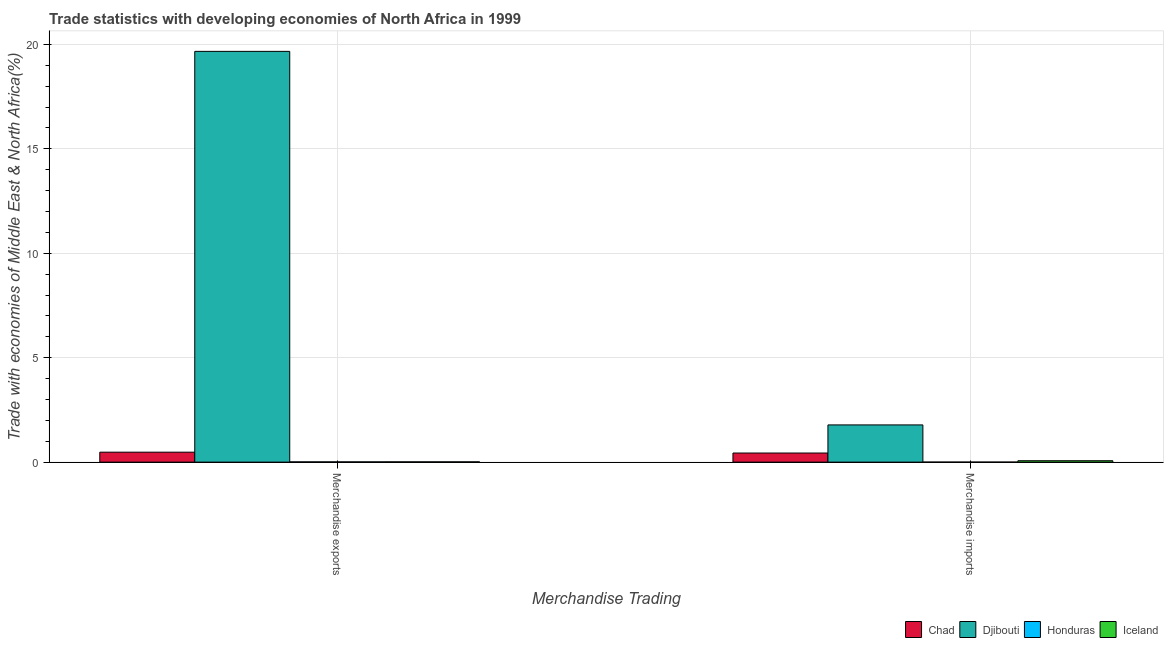How many groups of bars are there?
Your response must be concise. 2. What is the label of the 2nd group of bars from the left?
Make the answer very short. Merchandise imports. What is the merchandise imports in Honduras?
Provide a succinct answer. 0. Across all countries, what is the maximum merchandise exports?
Provide a succinct answer. 19.67. Across all countries, what is the minimum merchandise imports?
Offer a very short reply. 0. In which country was the merchandise imports maximum?
Offer a very short reply. Djibouti. In which country was the merchandise exports minimum?
Give a very brief answer. Honduras. What is the total merchandise imports in the graph?
Keep it short and to the point. 2.29. What is the difference between the merchandise exports in Iceland and that in Djibouti?
Ensure brevity in your answer.  -19.66. What is the difference between the merchandise imports in Chad and the merchandise exports in Honduras?
Make the answer very short. 0.42. What is the average merchandise imports per country?
Make the answer very short. 0.57. What is the difference between the merchandise imports and merchandise exports in Djibouti?
Your answer should be very brief. -17.89. In how many countries, is the merchandise exports greater than 14 %?
Offer a terse response. 1. What is the ratio of the merchandise exports in Djibouti to that in Honduras?
Give a very brief answer. 1712.15. Is the merchandise exports in Djibouti less than that in Honduras?
Keep it short and to the point. No. What does the 1st bar from the left in Merchandise exports represents?
Provide a short and direct response. Chad. How many bars are there?
Offer a very short reply. 8. Are all the bars in the graph horizontal?
Give a very brief answer. No. How many countries are there in the graph?
Provide a short and direct response. 4. What is the difference between two consecutive major ticks on the Y-axis?
Your answer should be very brief. 5. Are the values on the major ticks of Y-axis written in scientific E-notation?
Provide a succinct answer. No. Does the graph contain any zero values?
Your answer should be very brief. No. Does the graph contain grids?
Ensure brevity in your answer.  Yes. Where does the legend appear in the graph?
Provide a succinct answer. Bottom right. How are the legend labels stacked?
Your response must be concise. Horizontal. What is the title of the graph?
Your answer should be very brief. Trade statistics with developing economies of North Africa in 1999. What is the label or title of the X-axis?
Provide a succinct answer. Merchandise Trading. What is the label or title of the Y-axis?
Provide a succinct answer. Trade with economies of Middle East & North Africa(%). What is the Trade with economies of Middle East & North Africa(%) in Chad in Merchandise exports?
Keep it short and to the point. 0.48. What is the Trade with economies of Middle East & North Africa(%) in Djibouti in Merchandise exports?
Keep it short and to the point. 19.67. What is the Trade with economies of Middle East & North Africa(%) in Honduras in Merchandise exports?
Your answer should be very brief. 0.01. What is the Trade with economies of Middle East & North Africa(%) of Iceland in Merchandise exports?
Give a very brief answer. 0.01. What is the Trade with economies of Middle East & North Africa(%) of Chad in Merchandise imports?
Provide a succinct answer. 0.44. What is the Trade with economies of Middle East & North Africa(%) of Djibouti in Merchandise imports?
Offer a very short reply. 1.78. What is the Trade with economies of Middle East & North Africa(%) in Honduras in Merchandise imports?
Your answer should be compact. 0. What is the Trade with economies of Middle East & North Africa(%) of Iceland in Merchandise imports?
Ensure brevity in your answer.  0.07. Across all Merchandise Trading, what is the maximum Trade with economies of Middle East & North Africa(%) in Chad?
Your response must be concise. 0.48. Across all Merchandise Trading, what is the maximum Trade with economies of Middle East & North Africa(%) in Djibouti?
Your answer should be compact. 19.67. Across all Merchandise Trading, what is the maximum Trade with economies of Middle East & North Africa(%) of Honduras?
Provide a short and direct response. 0.01. Across all Merchandise Trading, what is the maximum Trade with economies of Middle East & North Africa(%) of Iceland?
Provide a succinct answer. 0.07. Across all Merchandise Trading, what is the minimum Trade with economies of Middle East & North Africa(%) of Chad?
Offer a very short reply. 0.44. Across all Merchandise Trading, what is the minimum Trade with economies of Middle East & North Africa(%) in Djibouti?
Ensure brevity in your answer.  1.78. Across all Merchandise Trading, what is the minimum Trade with economies of Middle East & North Africa(%) of Honduras?
Give a very brief answer. 0. Across all Merchandise Trading, what is the minimum Trade with economies of Middle East & North Africa(%) in Iceland?
Provide a short and direct response. 0.01. What is the total Trade with economies of Middle East & North Africa(%) of Chad in the graph?
Make the answer very short. 0.91. What is the total Trade with economies of Middle East & North Africa(%) of Djibouti in the graph?
Provide a succinct answer. 21.45. What is the total Trade with economies of Middle East & North Africa(%) of Honduras in the graph?
Your answer should be compact. 0.01. What is the difference between the Trade with economies of Middle East & North Africa(%) of Chad in Merchandise exports and that in Merchandise imports?
Provide a succinct answer. 0.04. What is the difference between the Trade with economies of Middle East & North Africa(%) in Djibouti in Merchandise exports and that in Merchandise imports?
Make the answer very short. 17.89. What is the difference between the Trade with economies of Middle East & North Africa(%) in Honduras in Merchandise exports and that in Merchandise imports?
Make the answer very short. 0.01. What is the difference between the Trade with economies of Middle East & North Africa(%) in Iceland in Merchandise exports and that in Merchandise imports?
Your answer should be very brief. -0.05. What is the difference between the Trade with economies of Middle East & North Africa(%) in Chad in Merchandise exports and the Trade with economies of Middle East & North Africa(%) in Djibouti in Merchandise imports?
Offer a terse response. -1.31. What is the difference between the Trade with economies of Middle East & North Africa(%) in Chad in Merchandise exports and the Trade with economies of Middle East & North Africa(%) in Honduras in Merchandise imports?
Your response must be concise. 0.48. What is the difference between the Trade with economies of Middle East & North Africa(%) of Chad in Merchandise exports and the Trade with economies of Middle East & North Africa(%) of Iceland in Merchandise imports?
Your answer should be compact. 0.41. What is the difference between the Trade with economies of Middle East & North Africa(%) in Djibouti in Merchandise exports and the Trade with economies of Middle East & North Africa(%) in Honduras in Merchandise imports?
Your answer should be very brief. 19.67. What is the difference between the Trade with economies of Middle East & North Africa(%) of Djibouti in Merchandise exports and the Trade with economies of Middle East & North Africa(%) of Iceland in Merchandise imports?
Make the answer very short. 19.6. What is the difference between the Trade with economies of Middle East & North Africa(%) in Honduras in Merchandise exports and the Trade with economies of Middle East & North Africa(%) in Iceland in Merchandise imports?
Ensure brevity in your answer.  -0.06. What is the average Trade with economies of Middle East & North Africa(%) in Chad per Merchandise Trading?
Your response must be concise. 0.46. What is the average Trade with economies of Middle East & North Africa(%) of Djibouti per Merchandise Trading?
Keep it short and to the point. 10.73. What is the average Trade with economies of Middle East & North Africa(%) of Honduras per Merchandise Trading?
Make the answer very short. 0.01. What is the average Trade with economies of Middle East & North Africa(%) in Iceland per Merchandise Trading?
Your response must be concise. 0.04. What is the difference between the Trade with economies of Middle East & North Africa(%) in Chad and Trade with economies of Middle East & North Africa(%) in Djibouti in Merchandise exports?
Give a very brief answer. -19.19. What is the difference between the Trade with economies of Middle East & North Africa(%) in Chad and Trade with economies of Middle East & North Africa(%) in Honduras in Merchandise exports?
Provide a succinct answer. 0.46. What is the difference between the Trade with economies of Middle East & North Africa(%) in Chad and Trade with economies of Middle East & North Africa(%) in Iceland in Merchandise exports?
Ensure brevity in your answer.  0.46. What is the difference between the Trade with economies of Middle East & North Africa(%) in Djibouti and Trade with economies of Middle East & North Africa(%) in Honduras in Merchandise exports?
Make the answer very short. 19.66. What is the difference between the Trade with economies of Middle East & North Africa(%) in Djibouti and Trade with economies of Middle East & North Africa(%) in Iceland in Merchandise exports?
Provide a short and direct response. 19.66. What is the difference between the Trade with economies of Middle East & North Africa(%) of Honduras and Trade with economies of Middle East & North Africa(%) of Iceland in Merchandise exports?
Provide a succinct answer. -0. What is the difference between the Trade with economies of Middle East & North Africa(%) of Chad and Trade with economies of Middle East & North Africa(%) of Djibouti in Merchandise imports?
Ensure brevity in your answer.  -1.35. What is the difference between the Trade with economies of Middle East & North Africa(%) of Chad and Trade with economies of Middle East & North Africa(%) of Honduras in Merchandise imports?
Ensure brevity in your answer.  0.44. What is the difference between the Trade with economies of Middle East & North Africa(%) of Chad and Trade with economies of Middle East & North Africa(%) of Iceland in Merchandise imports?
Your answer should be very brief. 0.37. What is the difference between the Trade with economies of Middle East & North Africa(%) of Djibouti and Trade with economies of Middle East & North Africa(%) of Honduras in Merchandise imports?
Your answer should be very brief. 1.78. What is the difference between the Trade with economies of Middle East & North Africa(%) of Djibouti and Trade with economies of Middle East & North Africa(%) of Iceland in Merchandise imports?
Ensure brevity in your answer.  1.71. What is the difference between the Trade with economies of Middle East & North Africa(%) of Honduras and Trade with economies of Middle East & North Africa(%) of Iceland in Merchandise imports?
Offer a very short reply. -0.07. What is the ratio of the Trade with economies of Middle East & North Africa(%) in Chad in Merchandise exports to that in Merchandise imports?
Your answer should be very brief. 1.09. What is the ratio of the Trade with economies of Middle East & North Africa(%) of Djibouti in Merchandise exports to that in Merchandise imports?
Provide a short and direct response. 11.04. What is the ratio of the Trade with economies of Middle East & North Africa(%) in Honduras in Merchandise exports to that in Merchandise imports?
Offer a terse response. 17.93. What is the ratio of the Trade with economies of Middle East & North Africa(%) of Iceland in Merchandise exports to that in Merchandise imports?
Ensure brevity in your answer.  0.19. What is the difference between the highest and the second highest Trade with economies of Middle East & North Africa(%) of Chad?
Your answer should be very brief. 0.04. What is the difference between the highest and the second highest Trade with economies of Middle East & North Africa(%) in Djibouti?
Make the answer very short. 17.89. What is the difference between the highest and the second highest Trade with economies of Middle East & North Africa(%) in Honduras?
Give a very brief answer. 0.01. What is the difference between the highest and the second highest Trade with economies of Middle East & North Africa(%) of Iceland?
Make the answer very short. 0.05. What is the difference between the highest and the lowest Trade with economies of Middle East & North Africa(%) in Chad?
Provide a succinct answer. 0.04. What is the difference between the highest and the lowest Trade with economies of Middle East & North Africa(%) of Djibouti?
Give a very brief answer. 17.89. What is the difference between the highest and the lowest Trade with economies of Middle East & North Africa(%) of Honduras?
Your answer should be very brief. 0.01. What is the difference between the highest and the lowest Trade with economies of Middle East & North Africa(%) in Iceland?
Provide a succinct answer. 0.05. 